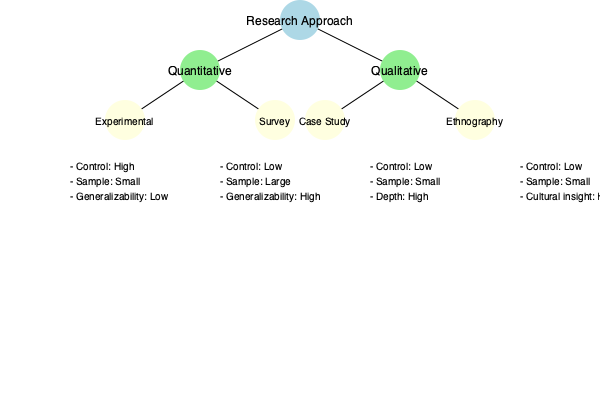Based on the decision tree comparing different research methodologies, which approach would be most suitable for a study aiming to understand the impact of a new teaching method on student performance, assuming you have access to multiple classrooms and can randomly assign students to different groups? To determine the most suitable research methodology for this study, let's analyze the requirements and compare them with the characteristics of each approach:

1. Research goal: To understand the impact of a new teaching method on student performance.
2. Available resources: Access to multiple classrooms and ability to randomly assign students to groups.

Now, let's examine each methodology:

a) Experimental (Quantitative):
   - High control: Allows manipulation of variables (teaching method)
   - Small sample: Not necessarily a limitation if multiple classrooms are available
   - Low generalizability: Can be improved with proper sampling and study design

b) Survey (Quantitative):
   - Low control: Not suitable for manipulating variables
   - Large sample: Matches available resources
   - High generalizability: Not as crucial for this specific study

c) Case Study (Qualitative):
   - Low control: Not ideal for comparing different groups
   - Small sample: Not utilizing all available resources
   - High depth: Not the primary focus for this study

d) Ethnography (Qualitative):
   - Low control: Not suitable for comparing different groups
   - Small sample: Not utilizing all available resources
   - High cultural insight: Not the primary focus for this study

Considering these factors, the experimental approach is the most suitable for this study because:

1. It allows high control over variables, enabling the comparison of the new teaching method with traditional methods.
2. Random assignment of students to different groups is possible, which is crucial for experimental design.
3. Multiple classrooms provide an adequate sample size for an experimental study.
4. The focus on understanding the impact of a specific intervention (new teaching method) aligns well with the experimental approach.

While the experimental approach has lower generalizability, this can be mitigated through careful study design and sampling methods.
Answer: Experimental approach 